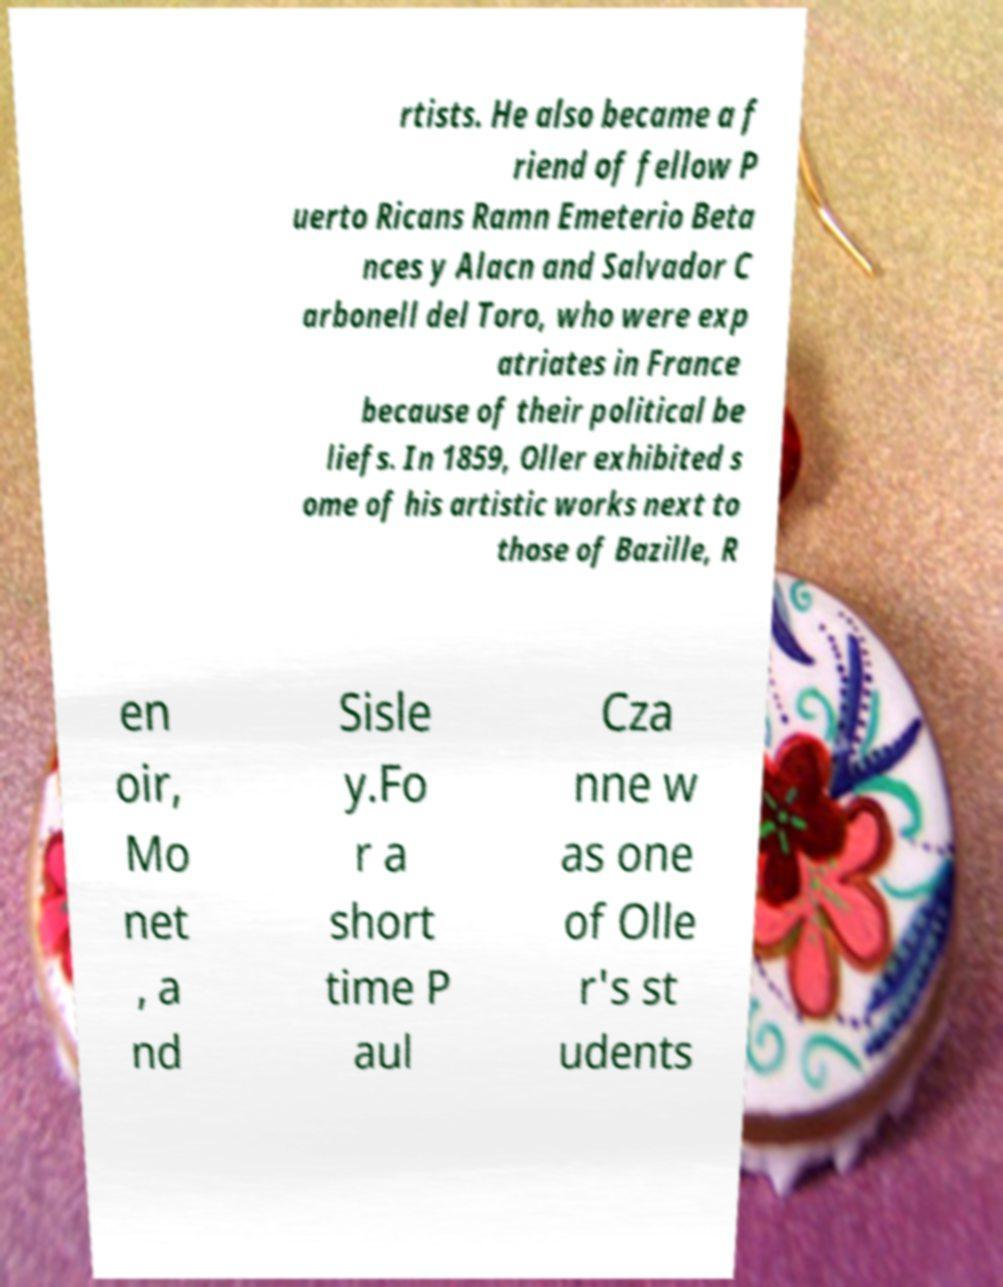Can you accurately transcribe the text from the provided image for me? rtists. He also became a f riend of fellow P uerto Ricans Ramn Emeterio Beta nces y Alacn and Salvador C arbonell del Toro, who were exp atriates in France because of their political be liefs. In 1859, Oller exhibited s ome of his artistic works next to those of Bazille, R en oir, Mo net , a nd Sisle y.Fo r a short time P aul Cza nne w as one of Olle r's st udents 